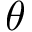Convert formula to latex. <formula><loc_0><loc_0><loc_500><loc_500>\theta</formula> 